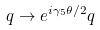<formula> <loc_0><loc_0><loc_500><loc_500>q \rightarrow e ^ { i \gamma _ { 5 } \theta / 2 } q</formula> 